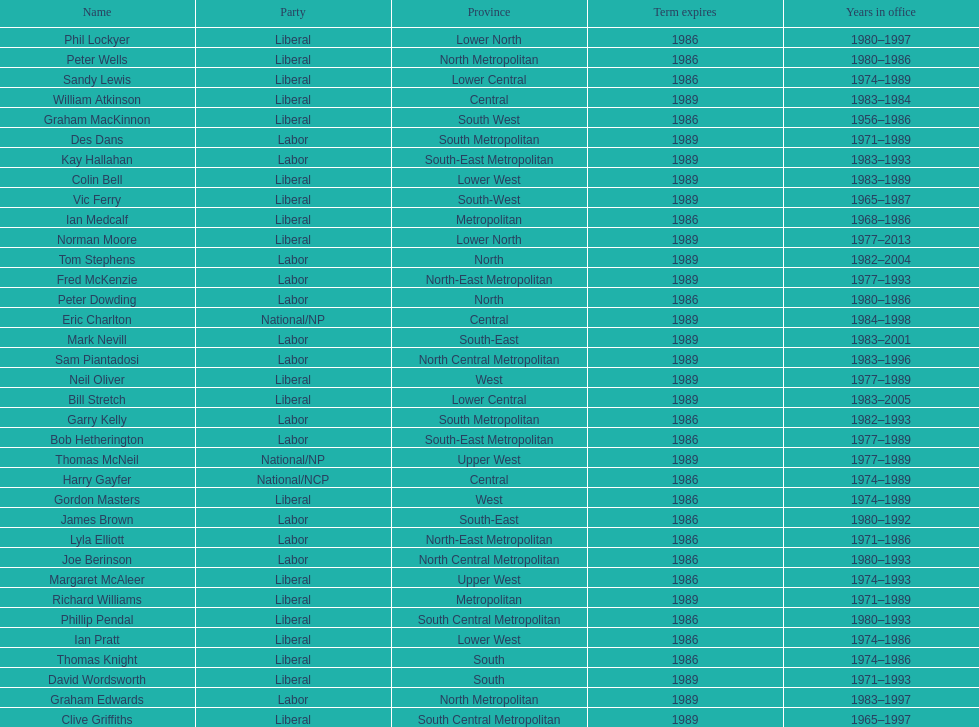Which party has the most membership? Liberal. 